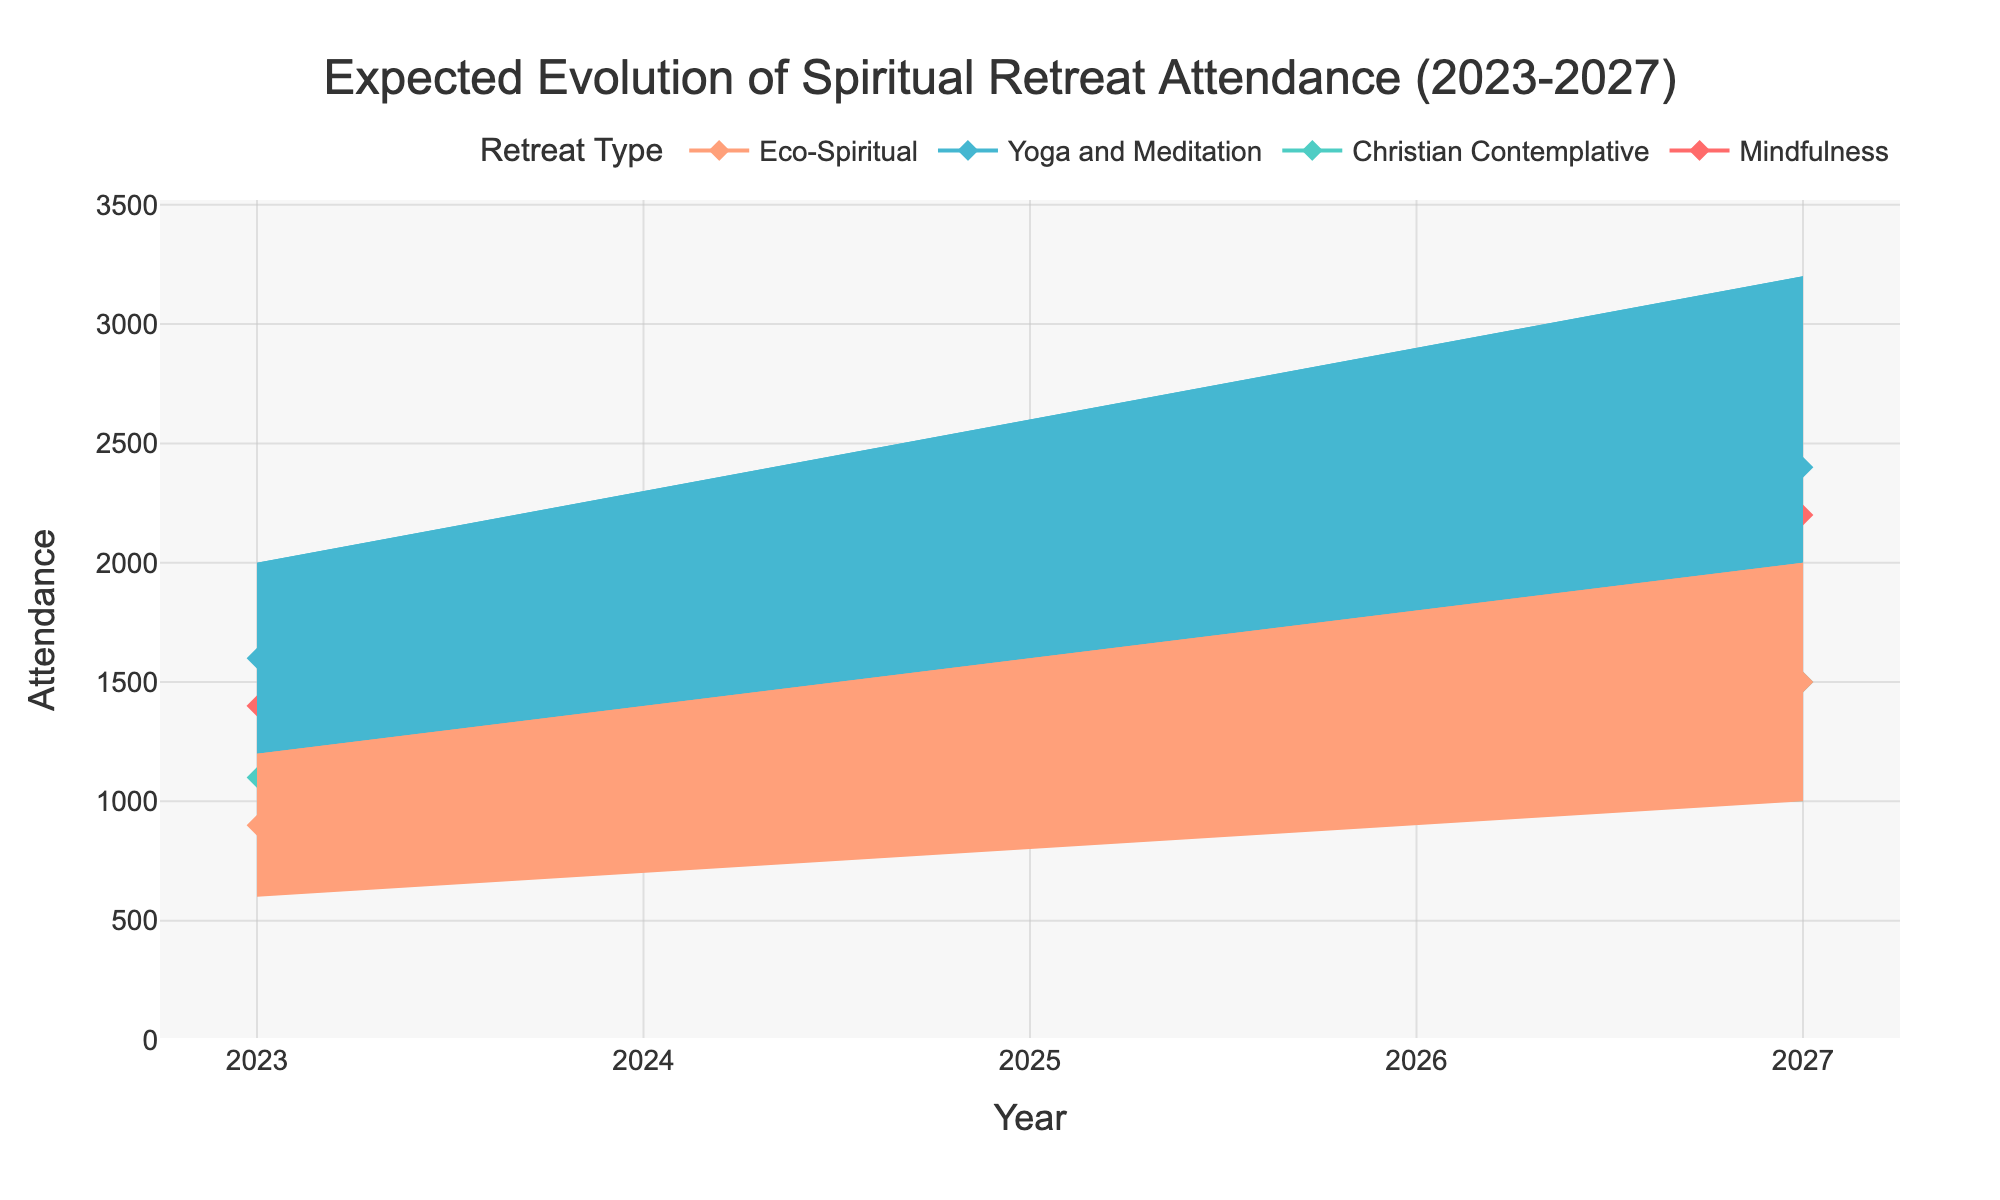what is the range of expected attendance for the Yoga and Meditation retreat in 2025? The figure shows the minimum (Lower Bound) and maximum (Upper Bound) expected attendances for each year and retreat type. For the Yoga and Meditation retreat in 2025, the Lower Bound is 1400 and the Upper Bound is 2600. Therefore, the range is 2600 - 1400 = 1200.
Answer: 1200 What is the median expected attendance for Missionfulness in 2026? To find the Median expected attendance, we look at the respective data point for Mindfulness retreat type in 2026. According to the figure's data, the median expected attendance in 2026 for Mindfulness is 2000.
Answer: 2000 What is the attendance increase for Christian Contemplative retreats from 2023 to 2024 at the median level? The median attendance in 2023 for Christian Contemplative retreats is 1100, and in 2024, it is 1200. The increase can be calculated as 1200 - 1100 = 100.
Answer: 100 Which retreat type is expected to have the highest attendance median in 2027? To answer this question, we compare the median values for all retreat types in 2027. According to the data, Yoga and Meditation has the highest median attendance of 2400 for 2027.
Answer: Yoga and Meditation What is the expected lower middle attendance for Eco-Spiritual retreats in 2024? The lower middle value is shown in the figure along with lower bound, median, upper middle, and upper bound. For Eco-Spiritual retreats in 2024, the lower middle attendance is 875.
Answer: 875 Which retreat type shows the most significant expected increase in attendance from 2023 to 2027 at the upper bound? By comparing the upper bound values from 2023 to 2027 for each retreat type, we calculate the differences. For Mindfulness, the increase is 3000 - 1800 = 1200; Christian Contemplative, 2000 - 1400 = 600; Yoga and Meditation, 3200 - 2000 = 1200; and Eco-Spiritual, 2000 - 1200 = 800. Therefore, Yoga and Meditation and Mindfulness both show the highest increase of 1200.
Answer: Yoga and Meditation, Mindfulness What is the median attendance for all retreat types combined in 2025? We find the median values for all retreat types in 2025: Mindfulness (1800), Christian Contemplative (1300), Yoga and Meditation (2000), and Eco-Spiritual (1200). Adding these, we get 1800 + 1300 + 2000 + 1200 = 6300. Dividing by 4 (number of retreat types), the combined median attendance is 6300 / 4 = 1575.
Answer: 1575 How does the median expected attendance for Eco-Spiritual retreats change from 2023 to 2027? Looking at the median values for Eco-Spiritual retreats in 2023 and 2027, we find 900 and 1500 respectively. The change is calculated as 1500 - 900 = 600.
Answer: 600 